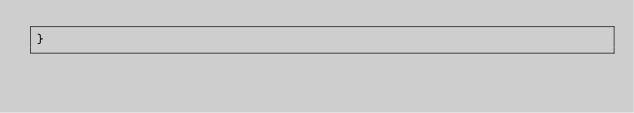<code> <loc_0><loc_0><loc_500><loc_500><_TypeScript_>}
</code> 